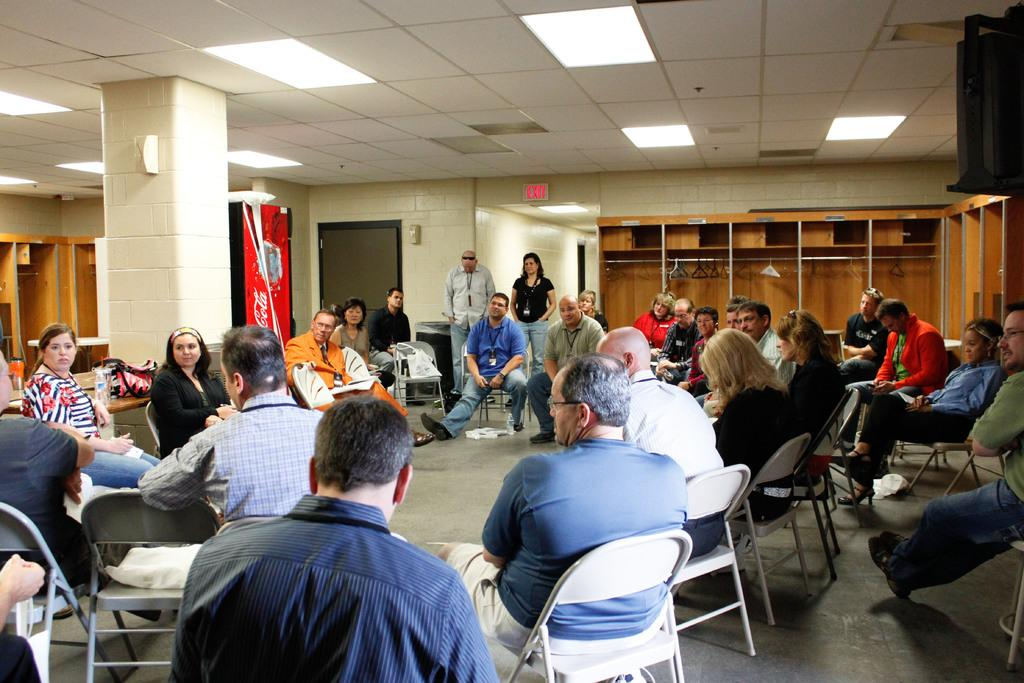What is the color of the wall in the image? The wall in the image is white. What are the people in the image doing? The people in the image are standing and sitting. What type of furniture is present in the image? There are chairs in the image. What type of breakfast is being served on the receipt in the image? There is no breakfast or receipt present in the image. How much salt is visible on the chairs in the image? There is no salt visible on the chairs in the image. 